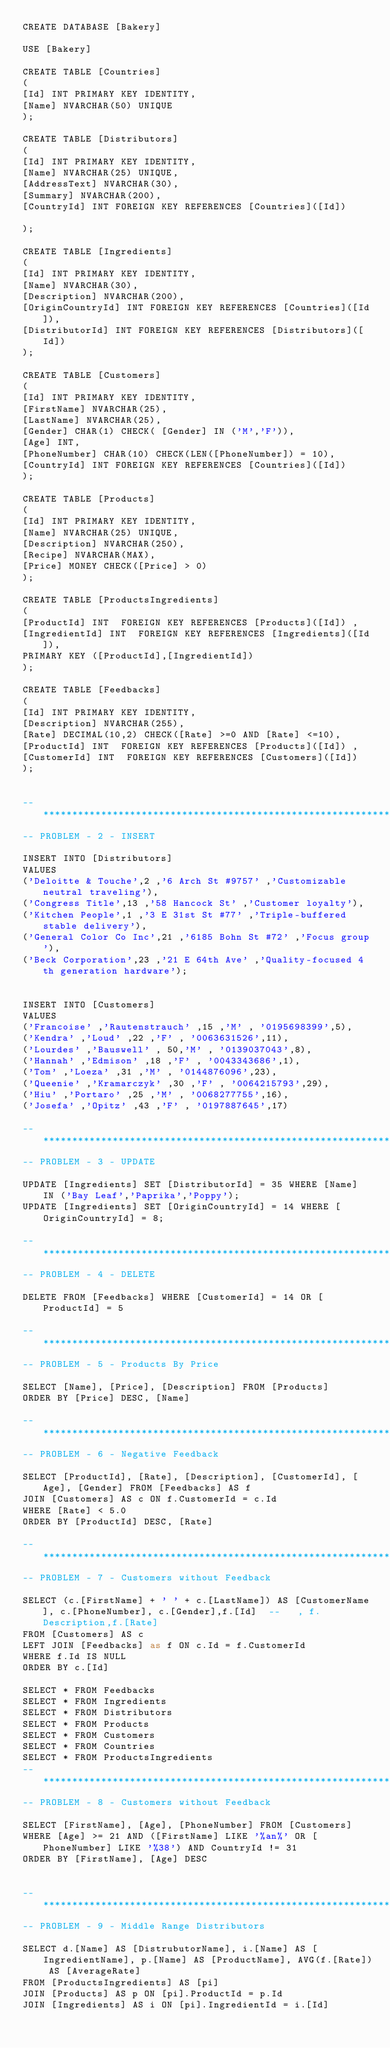<code> <loc_0><loc_0><loc_500><loc_500><_SQL_>CREATE DATABASE [Bakery]

USE [Bakery]

CREATE TABLE [Countries]
(
[Id] INT PRIMARY KEY IDENTITY,
[Name] NVARCHAR(50) UNIQUE
);

CREATE TABLE [Distributors]
(
[Id] INT PRIMARY KEY IDENTITY,
[Name] NVARCHAR(25) UNIQUE,
[AddressText] NVARCHAR(30),
[Summary] NVARCHAR(200),
[CountryId] INT FOREIGN KEY REFERENCES [Countries]([Id])

);

CREATE TABLE [Ingredients]
(
[Id] INT PRIMARY KEY IDENTITY,
[Name] NVARCHAR(30),
[Description] NVARCHAR(200),
[OriginCountryId] INT FOREIGN KEY REFERENCES [Countries]([Id]),
[DistributorId] INT FOREIGN KEY REFERENCES [Distributors]([Id])
);

CREATE TABLE [Customers]
(
[Id] INT PRIMARY KEY IDENTITY,
[FirstName] NVARCHAR(25),
[LastName] NVARCHAR(25),
[Gender] CHAR(1) CHECK( [Gender] IN ('M','F')),
[Age] INT,
[PhoneNumber] CHAR(10) CHECK(LEN([PhoneNumber]) = 10),
[CountryId] INT FOREIGN KEY REFERENCES [Countries]([Id])
);

CREATE TABLE [Products]
(
[Id] INT PRIMARY KEY IDENTITY,
[Name] NVARCHAR(25) UNIQUE,
[Description] NVARCHAR(250),
[Recipe] NVARCHAR(MAX),
[Price] MONEY CHECK([Price] > 0)
);

CREATE TABLE [ProductsIngredients]
(
[ProductId] INT  FOREIGN KEY REFERENCES [Products]([Id]) ,
[IngredientId] INT  FOREIGN KEY REFERENCES [Ingredients]([Id]),
PRIMARY KEY ([ProductId],[IngredientId])
);

CREATE TABLE [Feedbacks]
(
[Id] INT PRIMARY KEY IDENTITY,
[Description] NVARCHAR(255),
[Rate] DECIMAL(10,2) CHECK([Rate] >=0 AND [Rate] <=10),
[ProductId] INT  FOREIGN KEY REFERENCES [Products]([Id]) ,
[CustomerId] INT  FOREIGN KEY REFERENCES [Customers]([Id]) 
);


--*************************************************************************
-- PROBLEM - 2 - INSERT

INSERT INTO [Distributors] 
VALUES
('Deloitte & Touche',2 ,'6 Arch St #9757' ,'Customizable neutral traveling'),
('Congress Title',13 ,'58 Hancock St' ,'Customer loyalty'),
('Kitchen People',1 ,'3 E 31st St #77' ,'Triple-buffered stable delivery'),
('General Color Co Inc',21 ,'6185 Bohn St #72' ,'Focus group'),
('Beck Corporation',23 ,'21 E 64th Ave' ,'Quality-focused 4th generation hardware');


INSERT INTO [Customers] 
VALUES
('Francoise' ,'Rautenstrauch' ,15 ,'M' , '0195698399',5),
('Kendra' ,'Loud' ,22 ,'F' , '0063631526',11),
('Lourdes' ,'Bauswell' , 50,'M' , '0139037043',8),
('Hannah' ,'Edmison' ,18 ,'F' , '0043343686',1),
('Tom' ,'Loeza' ,31 ,'M' , '0144876096',23),
('Queenie' ,'Kramarczyk' ,30 ,'F' , '0064215793',29),
('Hiu' ,'Portaro' ,25 ,'M' , '0068277755',16),
('Josefa' ,'Opitz' ,43 ,'F' , '0197887645',17)

--*************************************************************************
-- PROBLEM - 3 - UPDATE

UPDATE [Ingredients] SET [DistributorId] = 35 WHERE [Name] IN ('Bay Leaf','Paprika','Poppy');
UPDATE [Ingredients] SET [OriginCountryId] = 14 WHERE [OriginCountryId] = 8;

--*************************************************************************
-- PROBLEM - 4 - DELETE

DELETE FROM [Feedbacks] WHERE [CustomerId] = 14 OR [ProductId] = 5

--*************************************************************************
-- PROBLEM - 5 - Products By Price

SELECT [Name], [Price], [Description] FROM [Products]
ORDER BY [Price] DESC, [Name]

--*************************************************************************
-- PROBLEM - 6 - Negative Feedback

SELECT [ProductId], [Rate], [Description], [CustomerId], [Age], [Gender] FROM [Feedbacks] AS f
JOIN [Customers] AS c ON f.CustomerId = c.Id
WHERE [Rate] < 5.0 
ORDER BY [ProductId] DESC, [Rate] 

--*************************************************************************
-- PROBLEM - 7 - Customers without Feedback

SELECT (c.[FirstName] + ' ' + c.[LastName]) AS [CustomerName], c.[PhoneNumber], c.[Gender],f.[Id]  --   , f.Description,f.[Rate]
FROM [Customers] AS c
LEFT JOIN [Feedbacks] as f ON c.Id = f.CustomerId
WHERE f.Id IS NULL 
ORDER BY c.[Id]

SELECT * FROM Feedbacks
SELECT * FROM Ingredients 
SELECT * FROM Distributors 
SELECT * FROM Products
SELECT * FROM Customers
SELECT * FROM Countries
SELECT * FROM ProductsIngredients
--*************************************************************************
-- PROBLEM - 8 - Customers without Feedback

SELECT [FirstName], [Age], [PhoneNumber] FROM [Customers]
WHERE [Age] >= 21 AND ([FirstName] LIKE '%an%' OR [PhoneNumber] LIKE '%38') AND CountryId != 31
ORDER BY [FirstName], [Age] DESC


--*************************************************************************
-- PROBLEM - 9 - Middle Range Distributors

SELECT d.[Name] AS [DistrubutorName], i.[Name] AS [IngredientName], p.[Name] AS [ProductName], AVG(f.[Rate]) AS [AverageRate] 
FROM [ProductsIngredients] AS [pi]
JOIN [Products] AS p ON [pi].ProductId = p.Id
JOIN [Ingredients] AS i ON [pi].IngredientId = i.[Id]</code> 